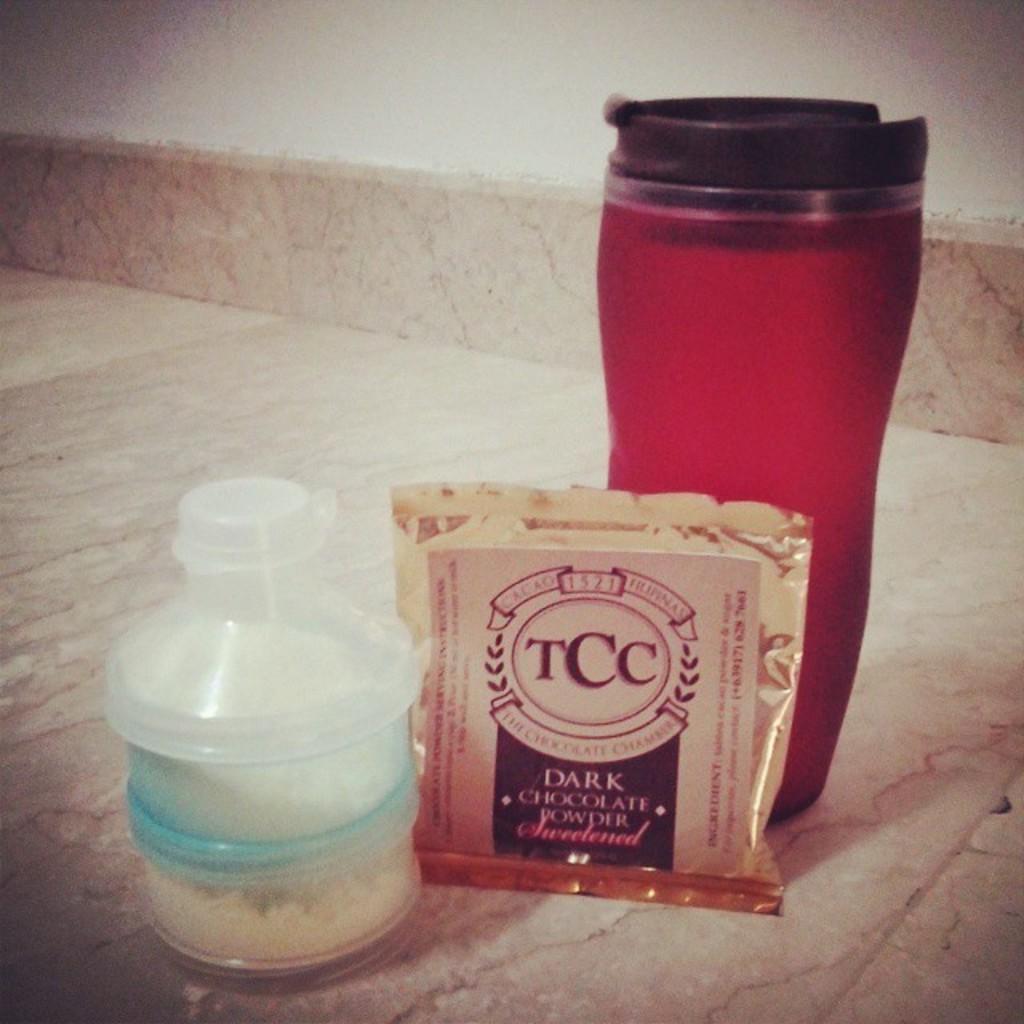What kind of powder is it?
Provide a short and direct response. Dark chocolate powder. 